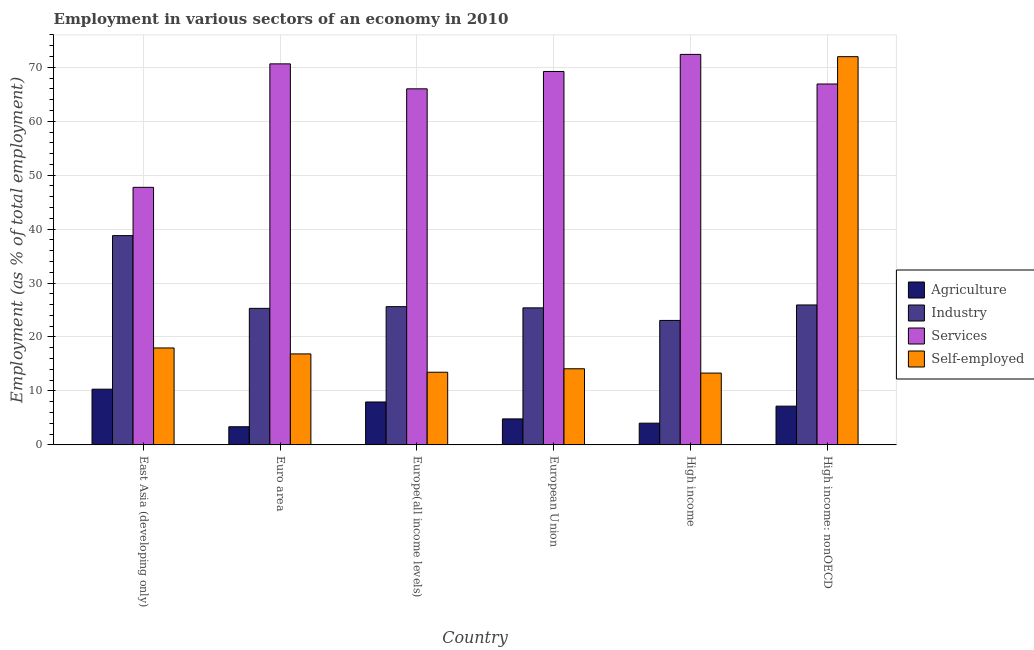How many different coloured bars are there?
Give a very brief answer. 4. How many groups of bars are there?
Keep it short and to the point. 6. Are the number of bars on each tick of the X-axis equal?
Make the answer very short. Yes. How many bars are there on the 2nd tick from the left?
Provide a succinct answer. 4. What is the label of the 3rd group of bars from the left?
Offer a very short reply. Europe(all income levels). In how many cases, is the number of bars for a given country not equal to the number of legend labels?
Provide a succinct answer. 0. What is the percentage of workers in agriculture in Euro area?
Keep it short and to the point. 3.35. Across all countries, what is the maximum percentage of self employed workers?
Your response must be concise. 71.98. Across all countries, what is the minimum percentage of self employed workers?
Offer a terse response. 13.3. In which country was the percentage of self employed workers maximum?
Offer a terse response. High income: nonOECD. In which country was the percentage of workers in industry minimum?
Offer a very short reply. High income. What is the total percentage of workers in agriculture in the graph?
Keep it short and to the point. 37.58. What is the difference between the percentage of workers in agriculture in Euro area and that in Europe(all income levels)?
Offer a very short reply. -4.59. What is the difference between the percentage of workers in industry in High income: nonOECD and the percentage of workers in agriculture in High income?
Offer a very short reply. 21.92. What is the average percentage of workers in services per country?
Your answer should be compact. 65.49. What is the difference between the percentage of workers in industry and percentage of workers in services in High income: nonOECD?
Ensure brevity in your answer.  -40.98. In how many countries, is the percentage of workers in industry greater than 54 %?
Your response must be concise. 0. What is the ratio of the percentage of workers in agriculture in East Asia (developing only) to that in Euro area?
Provide a succinct answer. 3.08. What is the difference between the highest and the second highest percentage of self employed workers?
Provide a short and direct response. 54.02. What is the difference between the highest and the lowest percentage of workers in industry?
Provide a succinct answer. 15.73. In how many countries, is the percentage of workers in services greater than the average percentage of workers in services taken over all countries?
Your response must be concise. 5. Is the sum of the percentage of workers in industry in High income and High income: nonOECD greater than the maximum percentage of workers in agriculture across all countries?
Provide a short and direct response. Yes. Is it the case that in every country, the sum of the percentage of workers in services and percentage of workers in agriculture is greater than the sum of percentage of self employed workers and percentage of workers in industry?
Your answer should be very brief. Yes. What does the 3rd bar from the left in Europe(all income levels) represents?
Your answer should be very brief. Services. What does the 2nd bar from the right in Europe(all income levels) represents?
Offer a very short reply. Services. How many bars are there?
Give a very brief answer. 24. What is the difference between two consecutive major ticks on the Y-axis?
Your response must be concise. 10. Are the values on the major ticks of Y-axis written in scientific E-notation?
Provide a short and direct response. No. Does the graph contain any zero values?
Offer a terse response. No. Does the graph contain grids?
Ensure brevity in your answer.  Yes. Where does the legend appear in the graph?
Your response must be concise. Center right. How many legend labels are there?
Provide a succinct answer. 4. What is the title of the graph?
Ensure brevity in your answer.  Employment in various sectors of an economy in 2010. What is the label or title of the Y-axis?
Your answer should be very brief. Employment (as % of total employment). What is the Employment (as % of total employment) in Agriculture in East Asia (developing only)?
Make the answer very short. 10.32. What is the Employment (as % of total employment) of Industry in East Asia (developing only)?
Your response must be concise. 38.79. What is the Employment (as % of total employment) of Services in East Asia (developing only)?
Your answer should be compact. 47.74. What is the Employment (as % of total employment) in Self-employed in East Asia (developing only)?
Your answer should be compact. 17.96. What is the Employment (as % of total employment) of Agriculture in Euro area?
Provide a succinct answer. 3.35. What is the Employment (as % of total employment) of Industry in Euro area?
Your answer should be compact. 25.3. What is the Employment (as % of total employment) in Services in Euro area?
Your answer should be very brief. 70.64. What is the Employment (as % of total employment) of Self-employed in Euro area?
Your answer should be very brief. 16.85. What is the Employment (as % of total employment) in Agriculture in Europe(all income levels)?
Your response must be concise. 7.94. What is the Employment (as % of total employment) in Industry in Europe(all income levels)?
Keep it short and to the point. 25.62. What is the Employment (as % of total employment) in Services in Europe(all income levels)?
Offer a very short reply. 66.01. What is the Employment (as % of total employment) of Self-employed in Europe(all income levels)?
Keep it short and to the point. 13.45. What is the Employment (as % of total employment) of Agriculture in European Union?
Give a very brief answer. 4.8. What is the Employment (as % of total employment) of Industry in European Union?
Make the answer very short. 25.4. What is the Employment (as % of total employment) in Services in European Union?
Your response must be concise. 69.23. What is the Employment (as % of total employment) in Self-employed in European Union?
Provide a short and direct response. 14.1. What is the Employment (as % of total employment) of Agriculture in High income?
Offer a very short reply. 4.01. What is the Employment (as % of total employment) of Industry in High income?
Offer a very short reply. 23.06. What is the Employment (as % of total employment) in Services in High income?
Your answer should be compact. 72.4. What is the Employment (as % of total employment) in Self-employed in High income?
Provide a succinct answer. 13.3. What is the Employment (as % of total employment) of Agriculture in High income: nonOECD?
Your answer should be very brief. 7.17. What is the Employment (as % of total employment) of Industry in High income: nonOECD?
Keep it short and to the point. 25.93. What is the Employment (as % of total employment) in Services in High income: nonOECD?
Your answer should be very brief. 66.91. What is the Employment (as % of total employment) of Self-employed in High income: nonOECD?
Your answer should be very brief. 71.98. Across all countries, what is the maximum Employment (as % of total employment) in Agriculture?
Provide a succinct answer. 10.32. Across all countries, what is the maximum Employment (as % of total employment) of Industry?
Ensure brevity in your answer.  38.79. Across all countries, what is the maximum Employment (as % of total employment) of Services?
Your answer should be very brief. 72.4. Across all countries, what is the maximum Employment (as % of total employment) of Self-employed?
Make the answer very short. 71.98. Across all countries, what is the minimum Employment (as % of total employment) of Agriculture?
Offer a very short reply. 3.35. Across all countries, what is the minimum Employment (as % of total employment) of Industry?
Provide a succinct answer. 23.06. Across all countries, what is the minimum Employment (as % of total employment) in Services?
Give a very brief answer. 47.74. Across all countries, what is the minimum Employment (as % of total employment) in Self-employed?
Offer a terse response. 13.3. What is the total Employment (as % of total employment) in Agriculture in the graph?
Give a very brief answer. 37.58. What is the total Employment (as % of total employment) in Industry in the graph?
Provide a short and direct response. 164.1. What is the total Employment (as % of total employment) in Services in the graph?
Provide a succinct answer. 392.94. What is the total Employment (as % of total employment) in Self-employed in the graph?
Make the answer very short. 147.64. What is the difference between the Employment (as % of total employment) in Agriculture in East Asia (developing only) and that in Euro area?
Make the answer very short. 6.97. What is the difference between the Employment (as % of total employment) of Industry in East Asia (developing only) and that in Euro area?
Offer a terse response. 13.49. What is the difference between the Employment (as % of total employment) in Services in East Asia (developing only) and that in Euro area?
Give a very brief answer. -22.9. What is the difference between the Employment (as % of total employment) of Self-employed in East Asia (developing only) and that in Euro area?
Your answer should be very brief. 1.11. What is the difference between the Employment (as % of total employment) in Agriculture in East Asia (developing only) and that in Europe(all income levels)?
Provide a succinct answer. 2.37. What is the difference between the Employment (as % of total employment) in Industry in East Asia (developing only) and that in Europe(all income levels)?
Your answer should be compact. 13.17. What is the difference between the Employment (as % of total employment) in Services in East Asia (developing only) and that in Europe(all income levels)?
Provide a short and direct response. -18.27. What is the difference between the Employment (as % of total employment) of Self-employed in East Asia (developing only) and that in Europe(all income levels)?
Your answer should be very brief. 4.5. What is the difference between the Employment (as % of total employment) of Agriculture in East Asia (developing only) and that in European Union?
Provide a short and direct response. 5.51. What is the difference between the Employment (as % of total employment) of Industry in East Asia (developing only) and that in European Union?
Give a very brief answer. 13.39. What is the difference between the Employment (as % of total employment) in Services in East Asia (developing only) and that in European Union?
Make the answer very short. -21.49. What is the difference between the Employment (as % of total employment) of Self-employed in East Asia (developing only) and that in European Union?
Your response must be concise. 3.86. What is the difference between the Employment (as % of total employment) in Agriculture in East Asia (developing only) and that in High income?
Provide a short and direct response. 6.3. What is the difference between the Employment (as % of total employment) in Industry in East Asia (developing only) and that in High income?
Ensure brevity in your answer.  15.73. What is the difference between the Employment (as % of total employment) in Services in East Asia (developing only) and that in High income?
Offer a very short reply. -24.65. What is the difference between the Employment (as % of total employment) in Self-employed in East Asia (developing only) and that in High income?
Offer a very short reply. 4.66. What is the difference between the Employment (as % of total employment) in Agriculture in East Asia (developing only) and that in High income: nonOECD?
Offer a very short reply. 3.15. What is the difference between the Employment (as % of total employment) in Industry in East Asia (developing only) and that in High income: nonOECD?
Your answer should be very brief. 12.86. What is the difference between the Employment (as % of total employment) in Services in East Asia (developing only) and that in High income: nonOECD?
Provide a short and direct response. -19.17. What is the difference between the Employment (as % of total employment) of Self-employed in East Asia (developing only) and that in High income: nonOECD?
Ensure brevity in your answer.  -54.02. What is the difference between the Employment (as % of total employment) in Agriculture in Euro area and that in Europe(all income levels)?
Offer a very short reply. -4.59. What is the difference between the Employment (as % of total employment) of Industry in Euro area and that in Europe(all income levels)?
Give a very brief answer. -0.32. What is the difference between the Employment (as % of total employment) of Services in Euro area and that in Europe(all income levels)?
Your answer should be very brief. 4.63. What is the difference between the Employment (as % of total employment) of Self-employed in Euro area and that in Europe(all income levels)?
Give a very brief answer. 3.4. What is the difference between the Employment (as % of total employment) of Agriculture in Euro area and that in European Union?
Provide a succinct answer. -1.45. What is the difference between the Employment (as % of total employment) of Industry in Euro area and that in European Union?
Your answer should be compact. -0.09. What is the difference between the Employment (as % of total employment) of Services in Euro area and that in European Union?
Ensure brevity in your answer.  1.41. What is the difference between the Employment (as % of total employment) of Self-employed in Euro area and that in European Union?
Your answer should be compact. 2.75. What is the difference between the Employment (as % of total employment) in Agriculture in Euro area and that in High income?
Provide a succinct answer. -0.66. What is the difference between the Employment (as % of total employment) in Industry in Euro area and that in High income?
Provide a short and direct response. 2.24. What is the difference between the Employment (as % of total employment) in Services in Euro area and that in High income?
Offer a terse response. -1.76. What is the difference between the Employment (as % of total employment) of Self-employed in Euro area and that in High income?
Offer a very short reply. 3.55. What is the difference between the Employment (as % of total employment) of Agriculture in Euro area and that in High income: nonOECD?
Provide a short and direct response. -3.82. What is the difference between the Employment (as % of total employment) in Industry in Euro area and that in High income: nonOECD?
Provide a succinct answer. -0.63. What is the difference between the Employment (as % of total employment) of Services in Euro area and that in High income: nonOECD?
Provide a succinct answer. 3.73. What is the difference between the Employment (as % of total employment) in Self-employed in Euro area and that in High income: nonOECD?
Give a very brief answer. -55.13. What is the difference between the Employment (as % of total employment) of Agriculture in Europe(all income levels) and that in European Union?
Ensure brevity in your answer.  3.14. What is the difference between the Employment (as % of total employment) of Industry in Europe(all income levels) and that in European Union?
Provide a short and direct response. 0.22. What is the difference between the Employment (as % of total employment) of Services in Europe(all income levels) and that in European Union?
Your response must be concise. -3.22. What is the difference between the Employment (as % of total employment) of Self-employed in Europe(all income levels) and that in European Union?
Your answer should be very brief. -0.64. What is the difference between the Employment (as % of total employment) of Agriculture in Europe(all income levels) and that in High income?
Your answer should be very brief. 3.93. What is the difference between the Employment (as % of total employment) of Industry in Europe(all income levels) and that in High income?
Ensure brevity in your answer.  2.55. What is the difference between the Employment (as % of total employment) in Services in Europe(all income levels) and that in High income?
Provide a succinct answer. -6.38. What is the difference between the Employment (as % of total employment) in Self-employed in Europe(all income levels) and that in High income?
Give a very brief answer. 0.16. What is the difference between the Employment (as % of total employment) of Agriculture in Europe(all income levels) and that in High income: nonOECD?
Make the answer very short. 0.77. What is the difference between the Employment (as % of total employment) in Industry in Europe(all income levels) and that in High income: nonOECD?
Provide a short and direct response. -0.31. What is the difference between the Employment (as % of total employment) in Services in Europe(all income levels) and that in High income: nonOECD?
Your answer should be compact. -0.9. What is the difference between the Employment (as % of total employment) of Self-employed in Europe(all income levels) and that in High income: nonOECD?
Ensure brevity in your answer.  -58.52. What is the difference between the Employment (as % of total employment) of Agriculture in European Union and that in High income?
Keep it short and to the point. 0.79. What is the difference between the Employment (as % of total employment) in Industry in European Union and that in High income?
Offer a terse response. 2.33. What is the difference between the Employment (as % of total employment) of Services in European Union and that in High income?
Offer a very short reply. -3.17. What is the difference between the Employment (as % of total employment) in Self-employed in European Union and that in High income?
Your response must be concise. 0.8. What is the difference between the Employment (as % of total employment) in Agriculture in European Union and that in High income: nonOECD?
Your response must be concise. -2.36. What is the difference between the Employment (as % of total employment) in Industry in European Union and that in High income: nonOECD?
Offer a terse response. -0.54. What is the difference between the Employment (as % of total employment) of Services in European Union and that in High income: nonOECD?
Offer a very short reply. 2.32. What is the difference between the Employment (as % of total employment) of Self-employed in European Union and that in High income: nonOECD?
Provide a short and direct response. -57.88. What is the difference between the Employment (as % of total employment) of Agriculture in High income and that in High income: nonOECD?
Your answer should be very brief. -3.16. What is the difference between the Employment (as % of total employment) of Industry in High income and that in High income: nonOECD?
Your answer should be compact. -2.87. What is the difference between the Employment (as % of total employment) in Services in High income and that in High income: nonOECD?
Your answer should be compact. 5.49. What is the difference between the Employment (as % of total employment) in Self-employed in High income and that in High income: nonOECD?
Make the answer very short. -58.68. What is the difference between the Employment (as % of total employment) in Agriculture in East Asia (developing only) and the Employment (as % of total employment) in Industry in Euro area?
Offer a very short reply. -14.99. What is the difference between the Employment (as % of total employment) in Agriculture in East Asia (developing only) and the Employment (as % of total employment) in Services in Euro area?
Provide a succinct answer. -60.33. What is the difference between the Employment (as % of total employment) in Agriculture in East Asia (developing only) and the Employment (as % of total employment) in Self-employed in Euro area?
Your answer should be compact. -6.54. What is the difference between the Employment (as % of total employment) in Industry in East Asia (developing only) and the Employment (as % of total employment) in Services in Euro area?
Ensure brevity in your answer.  -31.85. What is the difference between the Employment (as % of total employment) of Industry in East Asia (developing only) and the Employment (as % of total employment) of Self-employed in Euro area?
Ensure brevity in your answer.  21.94. What is the difference between the Employment (as % of total employment) in Services in East Asia (developing only) and the Employment (as % of total employment) in Self-employed in Euro area?
Keep it short and to the point. 30.89. What is the difference between the Employment (as % of total employment) of Agriculture in East Asia (developing only) and the Employment (as % of total employment) of Industry in Europe(all income levels)?
Make the answer very short. -15.3. What is the difference between the Employment (as % of total employment) of Agriculture in East Asia (developing only) and the Employment (as % of total employment) of Services in Europe(all income levels)?
Offer a terse response. -55.7. What is the difference between the Employment (as % of total employment) in Agriculture in East Asia (developing only) and the Employment (as % of total employment) in Self-employed in Europe(all income levels)?
Offer a very short reply. -3.14. What is the difference between the Employment (as % of total employment) of Industry in East Asia (developing only) and the Employment (as % of total employment) of Services in Europe(all income levels)?
Give a very brief answer. -27.22. What is the difference between the Employment (as % of total employment) of Industry in East Asia (developing only) and the Employment (as % of total employment) of Self-employed in Europe(all income levels)?
Offer a very short reply. 25.34. What is the difference between the Employment (as % of total employment) of Services in East Asia (developing only) and the Employment (as % of total employment) of Self-employed in Europe(all income levels)?
Your answer should be very brief. 34.29. What is the difference between the Employment (as % of total employment) in Agriculture in East Asia (developing only) and the Employment (as % of total employment) in Industry in European Union?
Ensure brevity in your answer.  -15.08. What is the difference between the Employment (as % of total employment) in Agriculture in East Asia (developing only) and the Employment (as % of total employment) in Services in European Union?
Make the answer very short. -58.92. What is the difference between the Employment (as % of total employment) of Agriculture in East Asia (developing only) and the Employment (as % of total employment) of Self-employed in European Union?
Ensure brevity in your answer.  -3.78. What is the difference between the Employment (as % of total employment) in Industry in East Asia (developing only) and the Employment (as % of total employment) in Services in European Union?
Offer a very short reply. -30.44. What is the difference between the Employment (as % of total employment) of Industry in East Asia (developing only) and the Employment (as % of total employment) of Self-employed in European Union?
Your answer should be compact. 24.69. What is the difference between the Employment (as % of total employment) in Services in East Asia (developing only) and the Employment (as % of total employment) in Self-employed in European Union?
Your answer should be very brief. 33.65. What is the difference between the Employment (as % of total employment) of Agriculture in East Asia (developing only) and the Employment (as % of total employment) of Industry in High income?
Offer a terse response. -12.75. What is the difference between the Employment (as % of total employment) of Agriculture in East Asia (developing only) and the Employment (as % of total employment) of Services in High income?
Offer a very short reply. -62.08. What is the difference between the Employment (as % of total employment) in Agriculture in East Asia (developing only) and the Employment (as % of total employment) in Self-employed in High income?
Make the answer very short. -2.98. What is the difference between the Employment (as % of total employment) of Industry in East Asia (developing only) and the Employment (as % of total employment) of Services in High income?
Your response must be concise. -33.61. What is the difference between the Employment (as % of total employment) of Industry in East Asia (developing only) and the Employment (as % of total employment) of Self-employed in High income?
Give a very brief answer. 25.49. What is the difference between the Employment (as % of total employment) of Services in East Asia (developing only) and the Employment (as % of total employment) of Self-employed in High income?
Ensure brevity in your answer.  34.45. What is the difference between the Employment (as % of total employment) of Agriculture in East Asia (developing only) and the Employment (as % of total employment) of Industry in High income: nonOECD?
Offer a terse response. -15.62. What is the difference between the Employment (as % of total employment) of Agriculture in East Asia (developing only) and the Employment (as % of total employment) of Services in High income: nonOECD?
Offer a very short reply. -56.59. What is the difference between the Employment (as % of total employment) of Agriculture in East Asia (developing only) and the Employment (as % of total employment) of Self-employed in High income: nonOECD?
Your response must be concise. -61.66. What is the difference between the Employment (as % of total employment) in Industry in East Asia (developing only) and the Employment (as % of total employment) in Services in High income: nonOECD?
Offer a very short reply. -28.12. What is the difference between the Employment (as % of total employment) in Industry in East Asia (developing only) and the Employment (as % of total employment) in Self-employed in High income: nonOECD?
Keep it short and to the point. -33.19. What is the difference between the Employment (as % of total employment) in Services in East Asia (developing only) and the Employment (as % of total employment) in Self-employed in High income: nonOECD?
Keep it short and to the point. -24.23. What is the difference between the Employment (as % of total employment) of Agriculture in Euro area and the Employment (as % of total employment) of Industry in Europe(all income levels)?
Your answer should be compact. -22.27. What is the difference between the Employment (as % of total employment) of Agriculture in Euro area and the Employment (as % of total employment) of Services in Europe(all income levels)?
Your response must be concise. -62.67. What is the difference between the Employment (as % of total employment) in Agriculture in Euro area and the Employment (as % of total employment) in Self-employed in Europe(all income levels)?
Your answer should be very brief. -10.11. What is the difference between the Employment (as % of total employment) in Industry in Euro area and the Employment (as % of total employment) in Services in Europe(all income levels)?
Keep it short and to the point. -40.71. What is the difference between the Employment (as % of total employment) in Industry in Euro area and the Employment (as % of total employment) in Self-employed in Europe(all income levels)?
Your answer should be very brief. 11.85. What is the difference between the Employment (as % of total employment) of Services in Euro area and the Employment (as % of total employment) of Self-employed in Europe(all income levels)?
Ensure brevity in your answer.  57.19. What is the difference between the Employment (as % of total employment) of Agriculture in Euro area and the Employment (as % of total employment) of Industry in European Union?
Provide a short and direct response. -22.05. What is the difference between the Employment (as % of total employment) in Agriculture in Euro area and the Employment (as % of total employment) in Services in European Union?
Provide a short and direct response. -65.88. What is the difference between the Employment (as % of total employment) of Agriculture in Euro area and the Employment (as % of total employment) of Self-employed in European Union?
Give a very brief answer. -10.75. What is the difference between the Employment (as % of total employment) in Industry in Euro area and the Employment (as % of total employment) in Services in European Union?
Your answer should be compact. -43.93. What is the difference between the Employment (as % of total employment) in Industry in Euro area and the Employment (as % of total employment) in Self-employed in European Union?
Offer a very short reply. 11.2. What is the difference between the Employment (as % of total employment) of Services in Euro area and the Employment (as % of total employment) of Self-employed in European Union?
Provide a short and direct response. 56.54. What is the difference between the Employment (as % of total employment) of Agriculture in Euro area and the Employment (as % of total employment) of Industry in High income?
Give a very brief answer. -19.72. What is the difference between the Employment (as % of total employment) of Agriculture in Euro area and the Employment (as % of total employment) of Services in High income?
Ensure brevity in your answer.  -69.05. What is the difference between the Employment (as % of total employment) of Agriculture in Euro area and the Employment (as % of total employment) of Self-employed in High income?
Offer a terse response. -9.95. What is the difference between the Employment (as % of total employment) of Industry in Euro area and the Employment (as % of total employment) of Services in High income?
Ensure brevity in your answer.  -47.1. What is the difference between the Employment (as % of total employment) of Industry in Euro area and the Employment (as % of total employment) of Self-employed in High income?
Keep it short and to the point. 12. What is the difference between the Employment (as % of total employment) of Services in Euro area and the Employment (as % of total employment) of Self-employed in High income?
Provide a short and direct response. 57.34. What is the difference between the Employment (as % of total employment) in Agriculture in Euro area and the Employment (as % of total employment) in Industry in High income: nonOECD?
Keep it short and to the point. -22.58. What is the difference between the Employment (as % of total employment) in Agriculture in Euro area and the Employment (as % of total employment) in Services in High income: nonOECD?
Ensure brevity in your answer.  -63.56. What is the difference between the Employment (as % of total employment) of Agriculture in Euro area and the Employment (as % of total employment) of Self-employed in High income: nonOECD?
Provide a short and direct response. -68.63. What is the difference between the Employment (as % of total employment) of Industry in Euro area and the Employment (as % of total employment) of Services in High income: nonOECD?
Offer a very short reply. -41.61. What is the difference between the Employment (as % of total employment) in Industry in Euro area and the Employment (as % of total employment) in Self-employed in High income: nonOECD?
Keep it short and to the point. -46.68. What is the difference between the Employment (as % of total employment) in Services in Euro area and the Employment (as % of total employment) in Self-employed in High income: nonOECD?
Your response must be concise. -1.34. What is the difference between the Employment (as % of total employment) of Agriculture in Europe(all income levels) and the Employment (as % of total employment) of Industry in European Union?
Give a very brief answer. -17.45. What is the difference between the Employment (as % of total employment) of Agriculture in Europe(all income levels) and the Employment (as % of total employment) of Services in European Union?
Provide a succinct answer. -61.29. What is the difference between the Employment (as % of total employment) in Agriculture in Europe(all income levels) and the Employment (as % of total employment) in Self-employed in European Union?
Your response must be concise. -6.16. What is the difference between the Employment (as % of total employment) of Industry in Europe(all income levels) and the Employment (as % of total employment) of Services in European Union?
Offer a very short reply. -43.61. What is the difference between the Employment (as % of total employment) in Industry in Europe(all income levels) and the Employment (as % of total employment) in Self-employed in European Union?
Give a very brief answer. 11.52. What is the difference between the Employment (as % of total employment) in Services in Europe(all income levels) and the Employment (as % of total employment) in Self-employed in European Union?
Ensure brevity in your answer.  51.92. What is the difference between the Employment (as % of total employment) in Agriculture in Europe(all income levels) and the Employment (as % of total employment) in Industry in High income?
Your answer should be very brief. -15.12. What is the difference between the Employment (as % of total employment) of Agriculture in Europe(all income levels) and the Employment (as % of total employment) of Services in High income?
Make the answer very short. -64.46. What is the difference between the Employment (as % of total employment) in Agriculture in Europe(all income levels) and the Employment (as % of total employment) in Self-employed in High income?
Offer a terse response. -5.36. What is the difference between the Employment (as % of total employment) of Industry in Europe(all income levels) and the Employment (as % of total employment) of Services in High income?
Give a very brief answer. -46.78. What is the difference between the Employment (as % of total employment) of Industry in Europe(all income levels) and the Employment (as % of total employment) of Self-employed in High income?
Offer a terse response. 12.32. What is the difference between the Employment (as % of total employment) in Services in Europe(all income levels) and the Employment (as % of total employment) in Self-employed in High income?
Your response must be concise. 52.72. What is the difference between the Employment (as % of total employment) in Agriculture in Europe(all income levels) and the Employment (as % of total employment) in Industry in High income: nonOECD?
Ensure brevity in your answer.  -17.99. What is the difference between the Employment (as % of total employment) of Agriculture in Europe(all income levels) and the Employment (as % of total employment) of Services in High income: nonOECD?
Your answer should be very brief. -58.97. What is the difference between the Employment (as % of total employment) in Agriculture in Europe(all income levels) and the Employment (as % of total employment) in Self-employed in High income: nonOECD?
Offer a terse response. -64.04. What is the difference between the Employment (as % of total employment) in Industry in Europe(all income levels) and the Employment (as % of total employment) in Services in High income: nonOECD?
Ensure brevity in your answer.  -41.29. What is the difference between the Employment (as % of total employment) in Industry in Europe(all income levels) and the Employment (as % of total employment) in Self-employed in High income: nonOECD?
Offer a terse response. -46.36. What is the difference between the Employment (as % of total employment) in Services in Europe(all income levels) and the Employment (as % of total employment) in Self-employed in High income: nonOECD?
Provide a short and direct response. -5.96. What is the difference between the Employment (as % of total employment) of Agriculture in European Union and the Employment (as % of total employment) of Industry in High income?
Keep it short and to the point. -18.26. What is the difference between the Employment (as % of total employment) of Agriculture in European Union and the Employment (as % of total employment) of Services in High income?
Offer a very short reply. -67.6. What is the difference between the Employment (as % of total employment) in Agriculture in European Union and the Employment (as % of total employment) in Self-employed in High income?
Provide a short and direct response. -8.5. What is the difference between the Employment (as % of total employment) in Industry in European Union and the Employment (as % of total employment) in Services in High income?
Offer a terse response. -47. What is the difference between the Employment (as % of total employment) in Industry in European Union and the Employment (as % of total employment) in Self-employed in High income?
Provide a short and direct response. 12.1. What is the difference between the Employment (as % of total employment) in Services in European Union and the Employment (as % of total employment) in Self-employed in High income?
Offer a terse response. 55.93. What is the difference between the Employment (as % of total employment) of Agriculture in European Union and the Employment (as % of total employment) of Industry in High income: nonOECD?
Offer a terse response. -21.13. What is the difference between the Employment (as % of total employment) in Agriculture in European Union and the Employment (as % of total employment) in Services in High income: nonOECD?
Keep it short and to the point. -62.11. What is the difference between the Employment (as % of total employment) of Agriculture in European Union and the Employment (as % of total employment) of Self-employed in High income: nonOECD?
Ensure brevity in your answer.  -67.18. What is the difference between the Employment (as % of total employment) of Industry in European Union and the Employment (as % of total employment) of Services in High income: nonOECD?
Provide a short and direct response. -41.51. What is the difference between the Employment (as % of total employment) of Industry in European Union and the Employment (as % of total employment) of Self-employed in High income: nonOECD?
Provide a short and direct response. -46.58. What is the difference between the Employment (as % of total employment) in Services in European Union and the Employment (as % of total employment) in Self-employed in High income: nonOECD?
Provide a short and direct response. -2.75. What is the difference between the Employment (as % of total employment) in Agriculture in High income and the Employment (as % of total employment) in Industry in High income: nonOECD?
Offer a very short reply. -21.92. What is the difference between the Employment (as % of total employment) of Agriculture in High income and the Employment (as % of total employment) of Services in High income: nonOECD?
Ensure brevity in your answer.  -62.9. What is the difference between the Employment (as % of total employment) of Agriculture in High income and the Employment (as % of total employment) of Self-employed in High income: nonOECD?
Offer a very short reply. -67.97. What is the difference between the Employment (as % of total employment) of Industry in High income and the Employment (as % of total employment) of Services in High income: nonOECD?
Make the answer very short. -43.85. What is the difference between the Employment (as % of total employment) of Industry in High income and the Employment (as % of total employment) of Self-employed in High income: nonOECD?
Give a very brief answer. -48.91. What is the difference between the Employment (as % of total employment) of Services in High income and the Employment (as % of total employment) of Self-employed in High income: nonOECD?
Provide a short and direct response. 0.42. What is the average Employment (as % of total employment) of Agriculture per country?
Keep it short and to the point. 6.26. What is the average Employment (as % of total employment) of Industry per country?
Your answer should be very brief. 27.35. What is the average Employment (as % of total employment) in Services per country?
Give a very brief answer. 65.49. What is the average Employment (as % of total employment) in Self-employed per country?
Keep it short and to the point. 24.61. What is the difference between the Employment (as % of total employment) in Agriculture and Employment (as % of total employment) in Industry in East Asia (developing only)?
Provide a short and direct response. -28.47. What is the difference between the Employment (as % of total employment) of Agriculture and Employment (as % of total employment) of Services in East Asia (developing only)?
Offer a very short reply. -37.43. What is the difference between the Employment (as % of total employment) of Agriculture and Employment (as % of total employment) of Self-employed in East Asia (developing only)?
Your answer should be compact. -7.64. What is the difference between the Employment (as % of total employment) of Industry and Employment (as % of total employment) of Services in East Asia (developing only)?
Your answer should be compact. -8.95. What is the difference between the Employment (as % of total employment) in Industry and Employment (as % of total employment) in Self-employed in East Asia (developing only)?
Your response must be concise. 20.83. What is the difference between the Employment (as % of total employment) in Services and Employment (as % of total employment) in Self-employed in East Asia (developing only)?
Your answer should be very brief. 29.79. What is the difference between the Employment (as % of total employment) of Agriculture and Employment (as % of total employment) of Industry in Euro area?
Your answer should be compact. -21.95. What is the difference between the Employment (as % of total employment) of Agriculture and Employment (as % of total employment) of Services in Euro area?
Ensure brevity in your answer.  -67.29. What is the difference between the Employment (as % of total employment) of Agriculture and Employment (as % of total employment) of Self-employed in Euro area?
Ensure brevity in your answer.  -13.5. What is the difference between the Employment (as % of total employment) of Industry and Employment (as % of total employment) of Services in Euro area?
Ensure brevity in your answer.  -45.34. What is the difference between the Employment (as % of total employment) in Industry and Employment (as % of total employment) in Self-employed in Euro area?
Your answer should be compact. 8.45. What is the difference between the Employment (as % of total employment) in Services and Employment (as % of total employment) in Self-employed in Euro area?
Your answer should be very brief. 53.79. What is the difference between the Employment (as % of total employment) of Agriculture and Employment (as % of total employment) of Industry in Europe(all income levels)?
Keep it short and to the point. -17.68. What is the difference between the Employment (as % of total employment) of Agriculture and Employment (as % of total employment) of Services in Europe(all income levels)?
Your answer should be very brief. -58.07. What is the difference between the Employment (as % of total employment) of Agriculture and Employment (as % of total employment) of Self-employed in Europe(all income levels)?
Keep it short and to the point. -5.51. What is the difference between the Employment (as % of total employment) in Industry and Employment (as % of total employment) in Services in Europe(all income levels)?
Provide a short and direct response. -40.4. What is the difference between the Employment (as % of total employment) of Industry and Employment (as % of total employment) of Self-employed in Europe(all income levels)?
Your answer should be compact. 12.16. What is the difference between the Employment (as % of total employment) in Services and Employment (as % of total employment) in Self-employed in Europe(all income levels)?
Give a very brief answer. 52.56. What is the difference between the Employment (as % of total employment) of Agriculture and Employment (as % of total employment) of Industry in European Union?
Offer a very short reply. -20.59. What is the difference between the Employment (as % of total employment) of Agriculture and Employment (as % of total employment) of Services in European Union?
Make the answer very short. -64.43. What is the difference between the Employment (as % of total employment) in Agriculture and Employment (as % of total employment) in Self-employed in European Union?
Give a very brief answer. -9.3. What is the difference between the Employment (as % of total employment) in Industry and Employment (as % of total employment) in Services in European Union?
Keep it short and to the point. -43.84. What is the difference between the Employment (as % of total employment) of Industry and Employment (as % of total employment) of Self-employed in European Union?
Keep it short and to the point. 11.3. What is the difference between the Employment (as % of total employment) in Services and Employment (as % of total employment) in Self-employed in European Union?
Give a very brief answer. 55.13. What is the difference between the Employment (as % of total employment) of Agriculture and Employment (as % of total employment) of Industry in High income?
Offer a very short reply. -19.05. What is the difference between the Employment (as % of total employment) in Agriculture and Employment (as % of total employment) in Services in High income?
Your answer should be compact. -68.39. What is the difference between the Employment (as % of total employment) in Agriculture and Employment (as % of total employment) in Self-employed in High income?
Provide a short and direct response. -9.29. What is the difference between the Employment (as % of total employment) in Industry and Employment (as % of total employment) in Services in High income?
Keep it short and to the point. -49.33. What is the difference between the Employment (as % of total employment) in Industry and Employment (as % of total employment) in Self-employed in High income?
Provide a succinct answer. 9.77. What is the difference between the Employment (as % of total employment) of Services and Employment (as % of total employment) of Self-employed in High income?
Give a very brief answer. 59.1. What is the difference between the Employment (as % of total employment) in Agriculture and Employment (as % of total employment) in Industry in High income: nonOECD?
Offer a terse response. -18.77. What is the difference between the Employment (as % of total employment) of Agriculture and Employment (as % of total employment) of Services in High income: nonOECD?
Provide a succinct answer. -59.74. What is the difference between the Employment (as % of total employment) in Agriculture and Employment (as % of total employment) in Self-employed in High income: nonOECD?
Keep it short and to the point. -64.81. What is the difference between the Employment (as % of total employment) of Industry and Employment (as % of total employment) of Services in High income: nonOECD?
Give a very brief answer. -40.98. What is the difference between the Employment (as % of total employment) in Industry and Employment (as % of total employment) in Self-employed in High income: nonOECD?
Make the answer very short. -46.05. What is the difference between the Employment (as % of total employment) of Services and Employment (as % of total employment) of Self-employed in High income: nonOECD?
Give a very brief answer. -5.07. What is the ratio of the Employment (as % of total employment) in Agriculture in East Asia (developing only) to that in Euro area?
Provide a short and direct response. 3.08. What is the ratio of the Employment (as % of total employment) of Industry in East Asia (developing only) to that in Euro area?
Provide a short and direct response. 1.53. What is the ratio of the Employment (as % of total employment) in Services in East Asia (developing only) to that in Euro area?
Ensure brevity in your answer.  0.68. What is the ratio of the Employment (as % of total employment) of Self-employed in East Asia (developing only) to that in Euro area?
Provide a short and direct response. 1.07. What is the ratio of the Employment (as % of total employment) in Agriculture in East Asia (developing only) to that in Europe(all income levels)?
Your answer should be very brief. 1.3. What is the ratio of the Employment (as % of total employment) in Industry in East Asia (developing only) to that in Europe(all income levels)?
Your answer should be compact. 1.51. What is the ratio of the Employment (as % of total employment) of Services in East Asia (developing only) to that in Europe(all income levels)?
Offer a very short reply. 0.72. What is the ratio of the Employment (as % of total employment) in Self-employed in East Asia (developing only) to that in Europe(all income levels)?
Ensure brevity in your answer.  1.33. What is the ratio of the Employment (as % of total employment) in Agriculture in East Asia (developing only) to that in European Union?
Your answer should be compact. 2.15. What is the ratio of the Employment (as % of total employment) in Industry in East Asia (developing only) to that in European Union?
Give a very brief answer. 1.53. What is the ratio of the Employment (as % of total employment) in Services in East Asia (developing only) to that in European Union?
Give a very brief answer. 0.69. What is the ratio of the Employment (as % of total employment) of Self-employed in East Asia (developing only) to that in European Union?
Keep it short and to the point. 1.27. What is the ratio of the Employment (as % of total employment) in Agriculture in East Asia (developing only) to that in High income?
Keep it short and to the point. 2.57. What is the ratio of the Employment (as % of total employment) in Industry in East Asia (developing only) to that in High income?
Offer a terse response. 1.68. What is the ratio of the Employment (as % of total employment) of Services in East Asia (developing only) to that in High income?
Make the answer very short. 0.66. What is the ratio of the Employment (as % of total employment) of Self-employed in East Asia (developing only) to that in High income?
Ensure brevity in your answer.  1.35. What is the ratio of the Employment (as % of total employment) in Agriculture in East Asia (developing only) to that in High income: nonOECD?
Provide a succinct answer. 1.44. What is the ratio of the Employment (as % of total employment) in Industry in East Asia (developing only) to that in High income: nonOECD?
Give a very brief answer. 1.5. What is the ratio of the Employment (as % of total employment) of Services in East Asia (developing only) to that in High income: nonOECD?
Provide a succinct answer. 0.71. What is the ratio of the Employment (as % of total employment) in Self-employed in East Asia (developing only) to that in High income: nonOECD?
Your response must be concise. 0.25. What is the ratio of the Employment (as % of total employment) of Agriculture in Euro area to that in Europe(all income levels)?
Ensure brevity in your answer.  0.42. What is the ratio of the Employment (as % of total employment) of Industry in Euro area to that in Europe(all income levels)?
Offer a terse response. 0.99. What is the ratio of the Employment (as % of total employment) of Services in Euro area to that in Europe(all income levels)?
Your response must be concise. 1.07. What is the ratio of the Employment (as % of total employment) of Self-employed in Euro area to that in Europe(all income levels)?
Give a very brief answer. 1.25. What is the ratio of the Employment (as % of total employment) in Agriculture in Euro area to that in European Union?
Offer a terse response. 0.7. What is the ratio of the Employment (as % of total employment) of Industry in Euro area to that in European Union?
Provide a short and direct response. 1. What is the ratio of the Employment (as % of total employment) in Services in Euro area to that in European Union?
Your response must be concise. 1.02. What is the ratio of the Employment (as % of total employment) of Self-employed in Euro area to that in European Union?
Offer a very short reply. 1.2. What is the ratio of the Employment (as % of total employment) in Agriculture in Euro area to that in High income?
Make the answer very short. 0.83. What is the ratio of the Employment (as % of total employment) in Industry in Euro area to that in High income?
Ensure brevity in your answer.  1.1. What is the ratio of the Employment (as % of total employment) in Services in Euro area to that in High income?
Offer a terse response. 0.98. What is the ratio of the Employment (as % of total employment) of Self-employed in Euro area to that in High income?
Provide a succinct answer. 1.27. What is the ratio of the Employment (as % of total employment) of Agriculture in Euro area to that in High income: nonOECD?
Your response must be concise. 0.47. What is the ratio of the Employment (as % of total employment) in Industry in Euro area to that in High income: nonOECD?
Make the answer very short. 0.98. What is the ratio of the Employment (as % of total employment) of Services in Euro area to that in High income: nonOECD?
Ensure brevity in your answer.  1.06. What is the ratio of the Employment (as % of total employment) of Self-employed in Euro area to that in High income: nonOECD?
Your answer should be very brief. 0.23. What is the ratio of the Employment (as % of total employment) of Agriculture in Europe(all income levels) to that in European Union?
Your response must be concise. 1.65. What is the ratio of the Employment (as % of total employment) in Industry in Europe(all income levels) to that in European Union?
Ensure brevity in your answer.  1.01. What is the ratio of the Employment (as % of total employment) of Services in Europe(all income levels) to that in European Union?
Your answer should be very brief. 0.95. What is the ratio of the Employment (as % of total employment) of Self-employed in Europe(all income levels) to that in European Union?
Give a very brief answer. 0.95. What is the ratio of the Employment (as % of total employment) of Agriculture in Europe(all income levels) to that in High income?
Make the answer very short. 1.98. What is the ratio of the Employment (as % of total employment) of Industry in Europe(all income levels) to that in High income?
Provide a short and direct response. 1.11. What is the ratio of the Employment (as % of total employment) of Services in Europe(all income levels) to that in High income?
Provide a succinct answer. 0.91. What is the ratio of the Employment (as % of total employment) in Self-employed in Europe(all income levels) to that in High income?
Your answer should be very brief. 1.01. What is the ratio of the Employment (as % of total employment) of Agriculture in Europe(all income levels) to that in High income: nonOECD?
Keep it short and to the point. 1.11. What is the ratio of the Employment (as % of total employment) of Industry in Europe(all income levels) to that in High income: nonOECD?
Provide a short and direct response. 0.99. What is the ratio of the Employment (as % of total employment) in Services in Europe(all income levels) to that in High income: nonOECD?
Keep it short and to the point. 0.99. What is the ratio of the Employment (as % of total employment) of Self-employed in Europe(all income levels) to that in High income: nonOECD?
Your answer should be very brief. 0.19. What is the ratio of the Employment (as % of total employment) in Agriculture in European Union to that in High income?
Offer a terse response. 1.2. What is the ratio of the Employment (as % of total employment) in Industry in European Union to that in High income?
Your response must be concise. 1.1. What is the ratio of the Employment (as % of total employment) of Services in European Union to that in High income?
Provide a succinct answer. 0.96. What is the ratio of the Employment (as % of total employment) in Self-employed in European Union to that in High income?
Ensure brevity in your answer.  1.06. What is the ratio of the Employment (as % of total employment) of Agriculture in European Union to that in High income: nonOECD?
Your answer should be very brief. 0.67. What is the ratio of the Employment (as % of total employment) in Industry in European Union to that in High income: nonOECD?
Your response must be concise. 0.98. What is the ratio of the Employment (as % of total employment) in Services in European Union to that in High income: nonOECD?
Your answer should be very brief. 1.03. What is the ratio of the Employment (as % of total employment) of Self-employed in European Union to that in High income: nonOECD?
Offer a terse response. 0.2. What is the ratio of the Employment (as % of total employment) in Agriculture in High income to that in High income: nonOECD?
Offer a very short reply. 0.56. What is the ratio of the Employment (as % of total employment) in Industry in High income to that in High income: nonOECD?
Make the answer very short. 0.89. What is the ratio of the Employment (as % of total employment) in Services in High income to that in High income: nonOECD?
Offer a very short reply. 1.08. What is the ratio of the Employment (as % of total employment) in Self-employed in High income to that in High income: nonOECD?
Provide a succinct answer. 0.18. What is the difference between the highest and the second highest Employment (as % of total employment) in Agriculture?
Provide a short and direct response. 2.37. What is the difference between the highest and the second highest Employment (as % of total employment) in Industry?
Give a very brief answer. 12.86. What is the difference between the highest and the second highest Employment (as % of total employment) of Services?
Offer a very short reply. 1.76. What is the difference between the highest and the second highest Employment (as % of total employment) of Self-employed?
Provide a succinct answer. 54.02. What is the difference between the highest and the lowest Employment (as % of total employment) in Agriculture?
Provide a succinct answer. 6.97. What is the difference between the highest and the lowest Employment (as % of total employment) of Industry?
Give a very brief answer. 15.73. What is the difference between the highest and the lowest Employment (as % of total employment) of Services?
Provide a succinct answer. 24.65. What is the difference between the highest and the lowest Employment (as % of total employment) in Self-employed?
Provide a short and direct response. 58.68. 